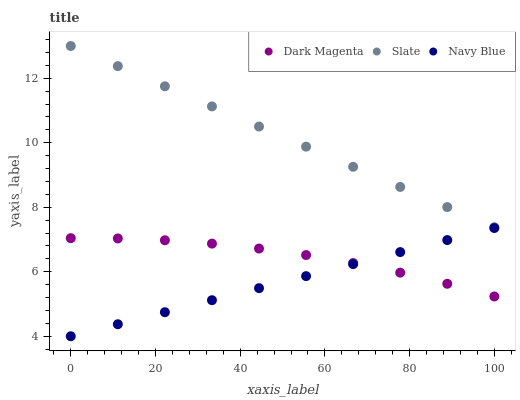Does Navy Blue have the minimum area under the curve?
Answer yes or no. Yes. Does Slate have the maximum area under the curve?
Answer yes or no. Yes. Does Dark Magenta have the minimum area under the curve?
Answer yes or no. No. Does Dark Magenta have the maximum area under the curve?
Answer yes or no. No. Is Navy Blue the smoothest?
Answer yes or no. Yes. Is Dark Magenta the roughest?
Answer yes or no. Yes. Is Slate the smoothest?
Answer yes or no. No. Is Slate the roughest?
Answer yes or no. No. Does Navy Blue have the lowest value?
Answer yes or no. Yes. Does Dark Magenta have the lowest value?
Answer yes or no. No. Does Slate have the highest value?
Answer yes or no. Yes. Does Dark Magenta have the highest value?
Answer yes or no. No. Is Dark Magenta less than Slate?
Answer yes or no. Yes. Is Slate greater than Navy Blue?
Answer yes or no. Yes. Does Navy Blue intersect Dark Magenta?
Answer yes or no. Yes. Is Navy Blue less than Dark Magenta?
Answer yes or no. No. Is Navy Blue greater than Dark Magenta?
Answer yes or no. No. Does Dark Magenta intersect Slate?
Answer yes or no. No. 